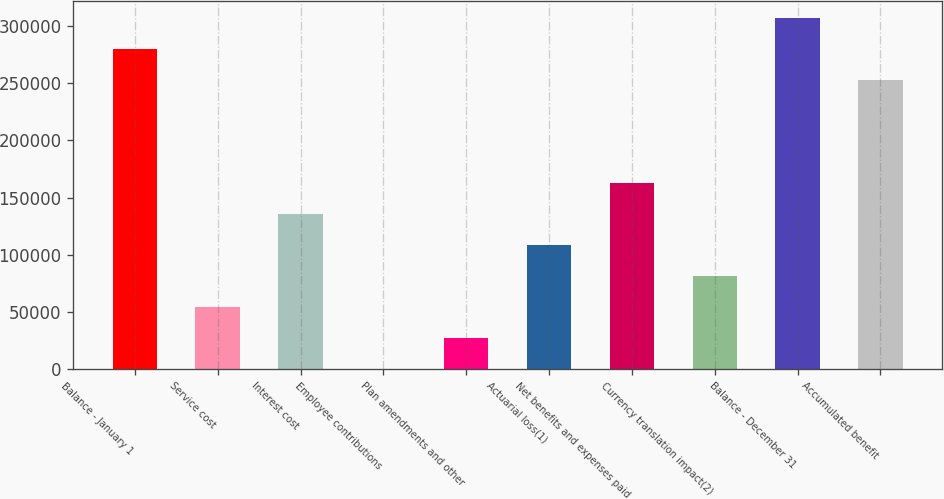Convert chart to OTSL. <chart><loc_0><loc_0><loc_500><loc_500><bar_chart><fcel>Balance - January 1<fcel>Service cost<fcel>Interest cost<fcel>Employee contributions<fcel>Plan amendments and other<fcel>Actuarial loss(1)<fcel>Net benefits and expenses paid<fcel>Currency translation impact(2)<fcel>Balance - December 31<fcel>Accumulated benefit<nl><fcel>279924<fcel>54603.6<fcel>135992<fcel>345<fcel>27474.3<fcel>108862<fcel>163121<fcel>81732.9<fcel>307054<fcel>252795<nl></chart> 